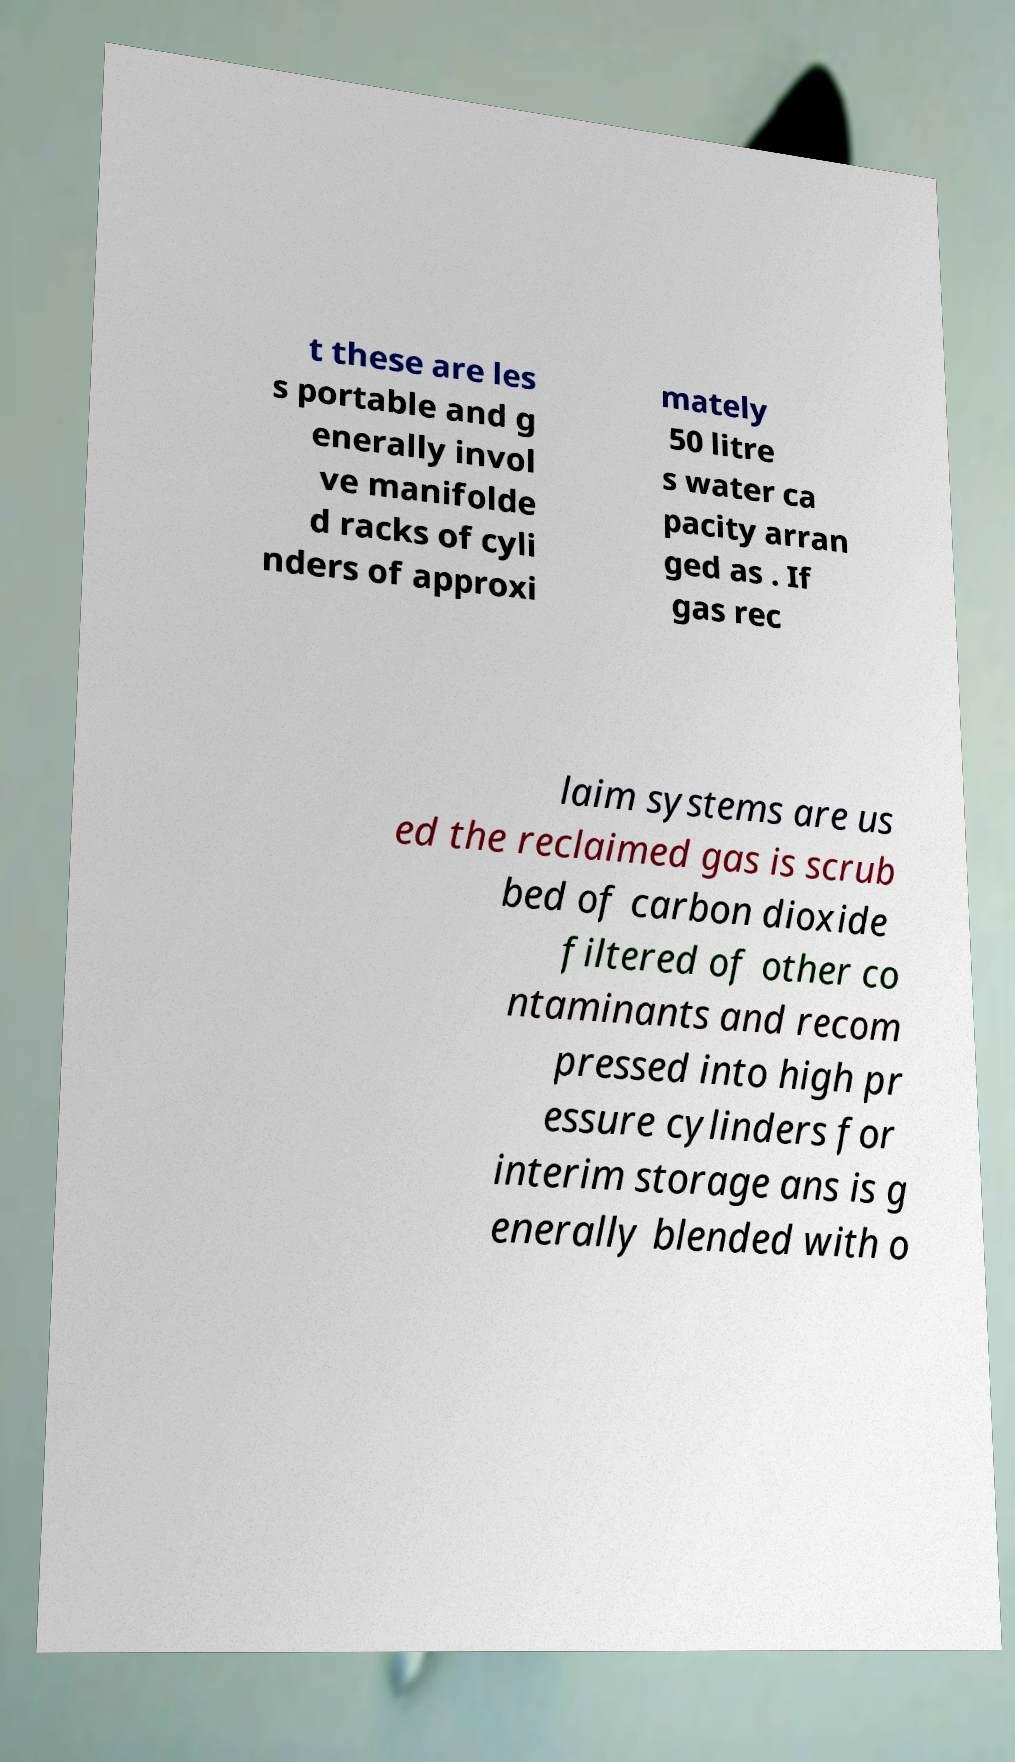I need the written content from this picture converted into text. Can you do that? t these are les s portable and g enerally invol ve manifolde d racks of cyli nders of approxi mately 50 litre s water ca pacity arran ged as . If gas rec laim systems are us ed the reclaimed gas is scrub bed of carbon dioxide filtered of other co ntaminants and recom pressed into high pr essure cylinders for interim storage ans is g enerally blended with o 